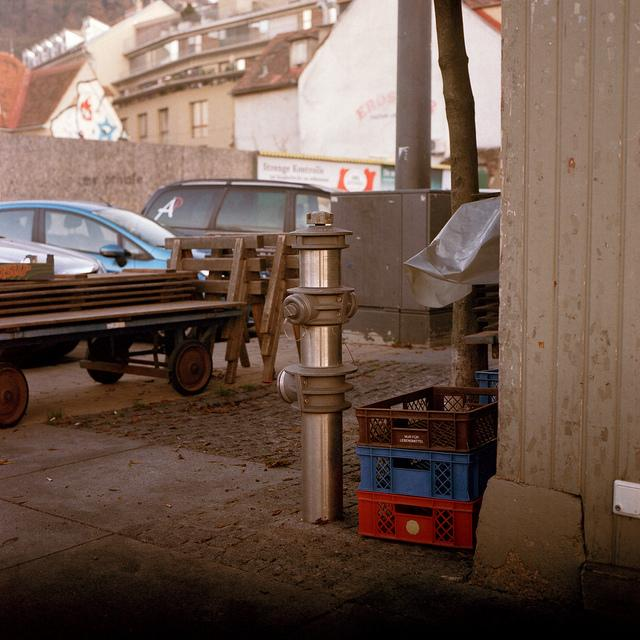What is stacked up near the wall on the right?

Choices:
A) books
B) crates
C) bowling pins
D) cones crates 